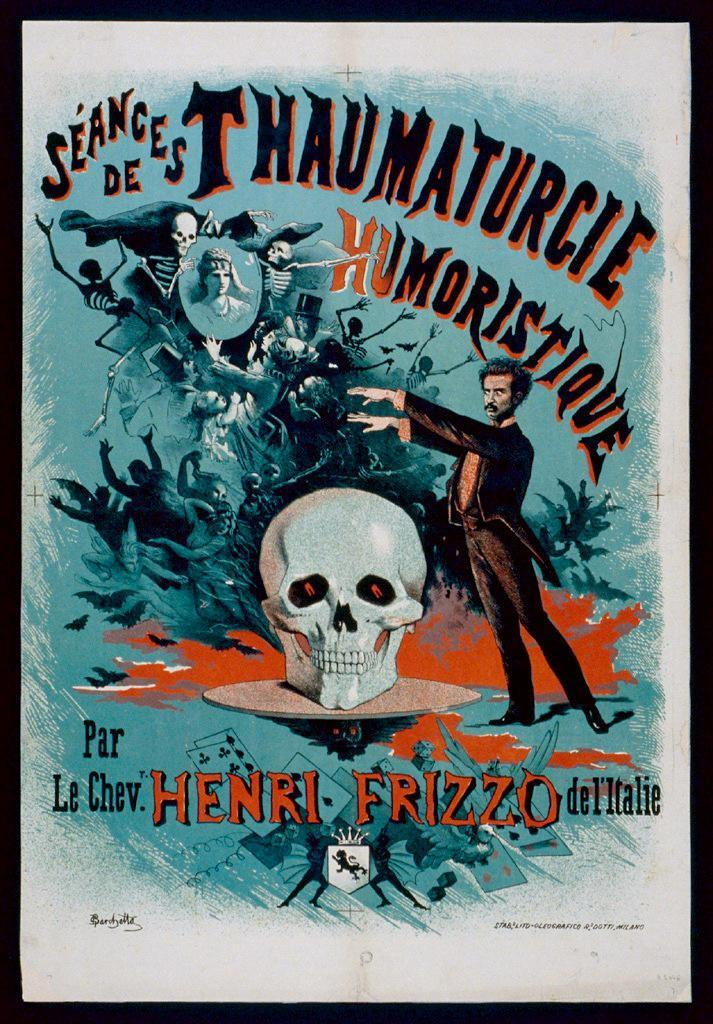<image>
Create a compact narrative representing the image presented. A man is in front of a giant skull, all of which is painted with the text "Par Le Chev. Henri Frizzo del Italie". 